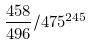<formula> <loc_0><loc_0><loc_500><loc_500>\frac { 4 5 8 } { 4 9 6 } / 4 7 5 ^ { 2 4 5 }</formula> 